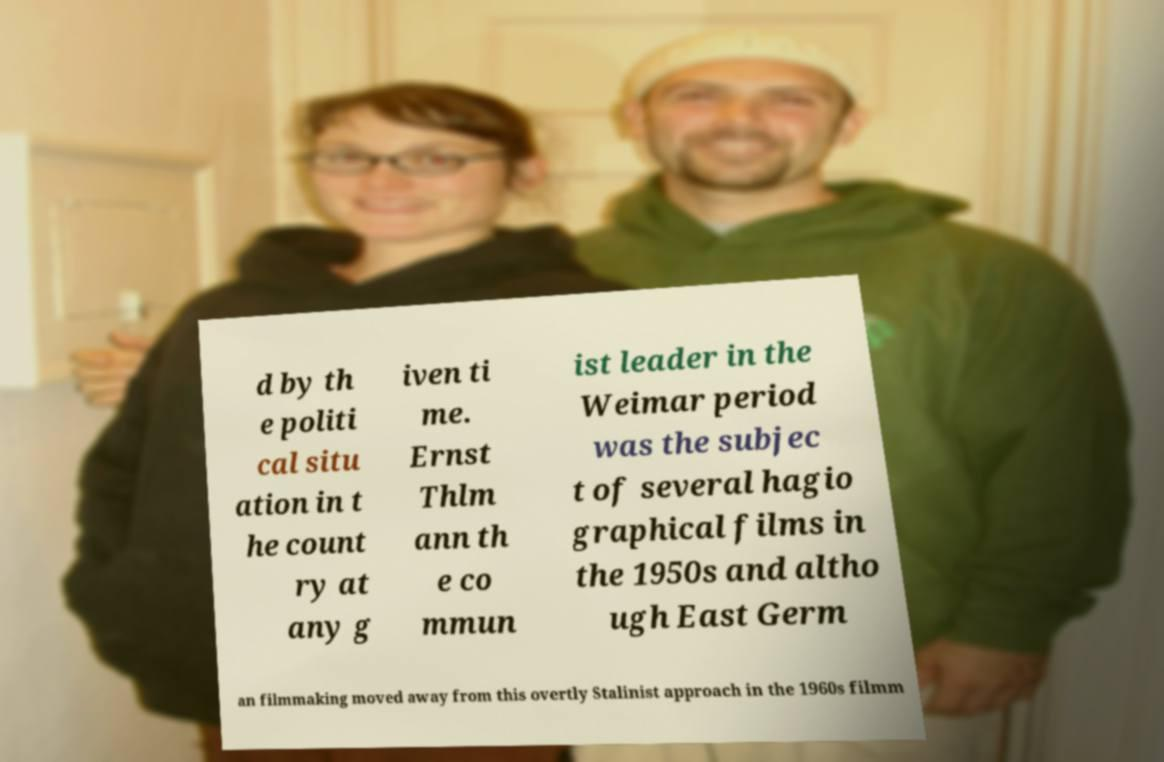Can you accurately transcribe the text from the provided image for me? d by th e politi cal situ ation in t he count ry at any g iven ti me. Ernst Thlm ann th e co mmun ist leader in the Weimar period was the subjec t of several hagio graphical films in the 1950s and altho ugh East Germ an filmmaking moved away from this overtly Stalinist approach in the 1960s filmm 